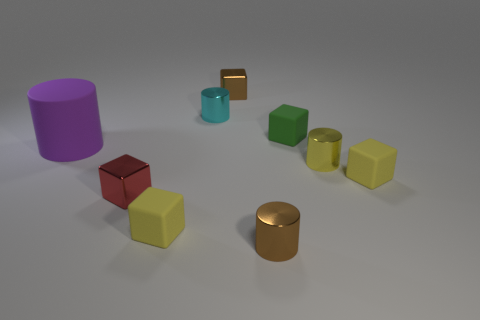Are there any other things that are the same size as the purple matte cylinder?
Ensure brevity in your answer.  No. What number of yellow things are either tiny metal things or tiny metallic cylinders?
Your answer should be very brief. 1. What is the size of the block that is right of the small brown metallic cylinder and behind the large purple rubber cylinder?
Offer a very short reply. Small. Is the number of yellow metallic things to the right of the small green rubber thing greater than the number of large gray metal cubes?
Offer a terse response. Yes. What number of cylinders are either blue objects or metallic things?
Your answer should be compact. 3. The rubber object that is on the right side of the large purple rubber cylinder and to the left of the small cyan metal cylinder has what shape?
Provide a succinct answer. Cube. Is the number of cyan metallic things that are on the right side of the red shiny thing the same as the number of brown things behind the big purple cylinder?
Provide a short and direct response. Yes. How many objects are large cyan things or small brown metal things?
Your answer should be very brief. 2. What color is the other metal block that is the same size as the red cube?
Your answer should be very brief. Brown. What number of things are tiny yellow matte objects to the left of the cyan cylinder or cylinders behind the tiny red metallic thing?
Offer a terse response. 4. 